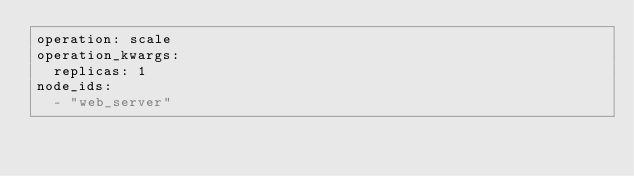Convert code to text. <code><loc_0><loc_0><loc_500><loc_500><_YAML_>operation: scale
operation_kwargs:
  replicas: 1
node_ids:
  - "web_server"
</code> 